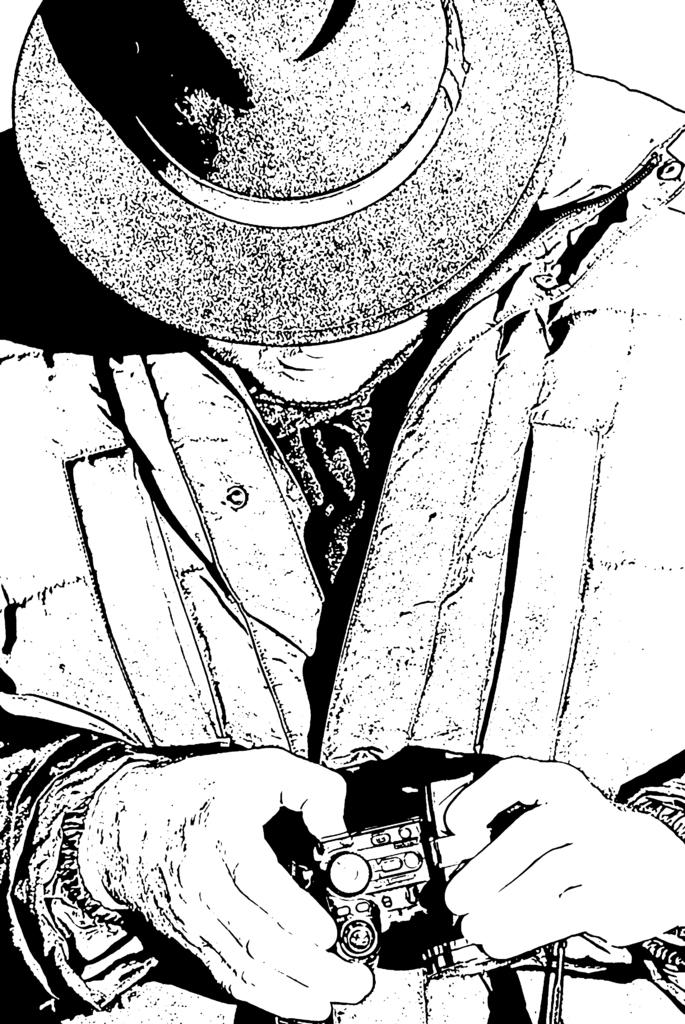What is the main subject of the image? The image contains an art piece. What does the art piece depict? The art piece depicts a person wearing a hat and jacket. What is the person holding in their hand? The person is holding an object in their hand. What is the color scheme of the art piece? The art piece is black and white in color. Can you tell me how many apples are in the cellar in the image? There is no mention of apples or a cellar in the image; the art piece depicts a person wearing a hat and jacket. 